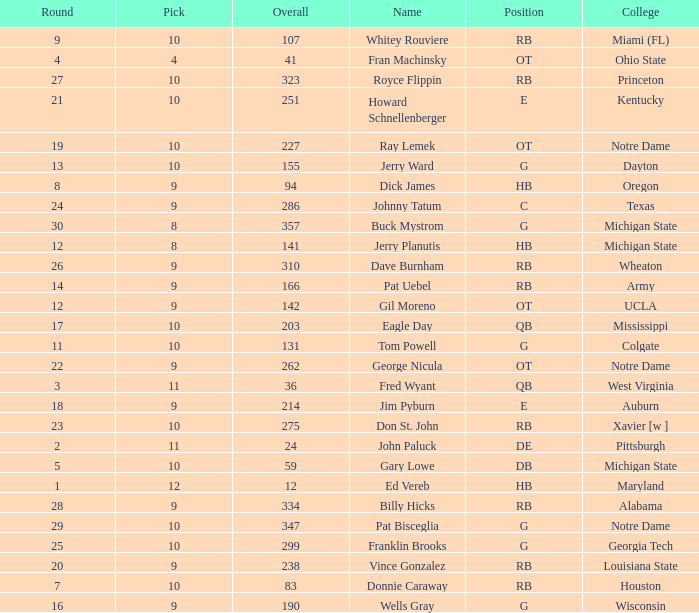What is the sum of rounds that has a pick of 9 and is named jim pyburn? 18.0. 